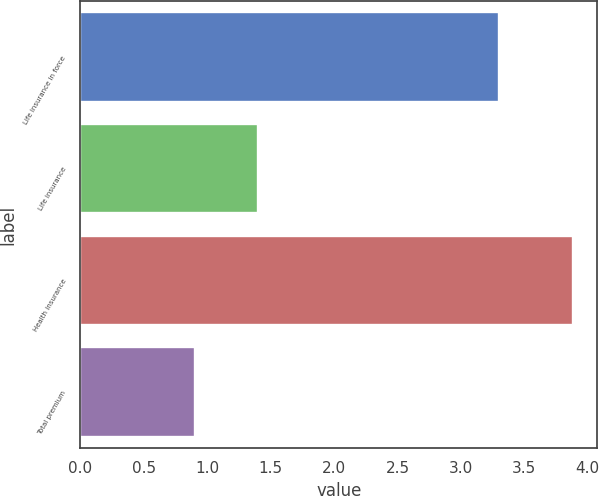Convert chart to OTSL. <chart><loc_0><loc_0><loc_500><loc_500><bar_chart><fcel>Life insurance in force<fcel>Life insurance<fcel>Health insurance<fcel>Total premium<nl><fcel>3.3<fcel>1.4<fcel>3.88<fcel>0.9<nl></chart> 